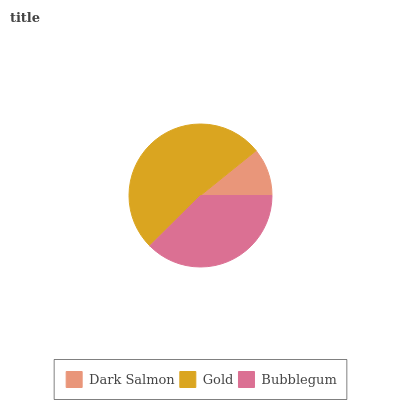Is Dark Salmon the minimum?
Answer yes or no. Yes. Is Gold the maximum?
Answer yes or no. Yes. Is Bubblegum the minimum?
Answer yes or no. No. Is Bubblegum the maximum?
Answer yes or no. No. Is Gold greater than Bubblegum?
Answer yes or no. Yes. Is Bubblegum less than Gold?
Answer yes or no. Yes. Is Bubblegum greater than Gold?
Answer yes or no. No. Is Gold less than Bubblegum?
Answer yes or no. No. Is Bubblegum the high median?
Answer yes or no. Yes. Is Bubblegum the low median?
Answer yes or no. Yes. Is Gold the high median?
Answer yes or no. No. Is Dark Salmon the low median?
Answer yes or no. No. 